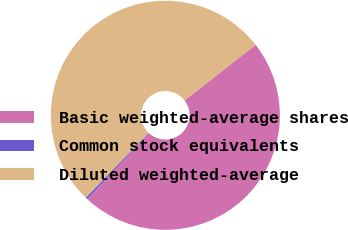Convert chart to OTSL. <chart><loc_0><loc_0><loc_500><loc_500><pie_chart><fcel>Basic weighted-average shares<fcel>Common stock equivalents<fcel>Diluted weighted-average<nl><fcel>47.47%<fcel>0.3%<fcel>52.22%<nl></chart> 